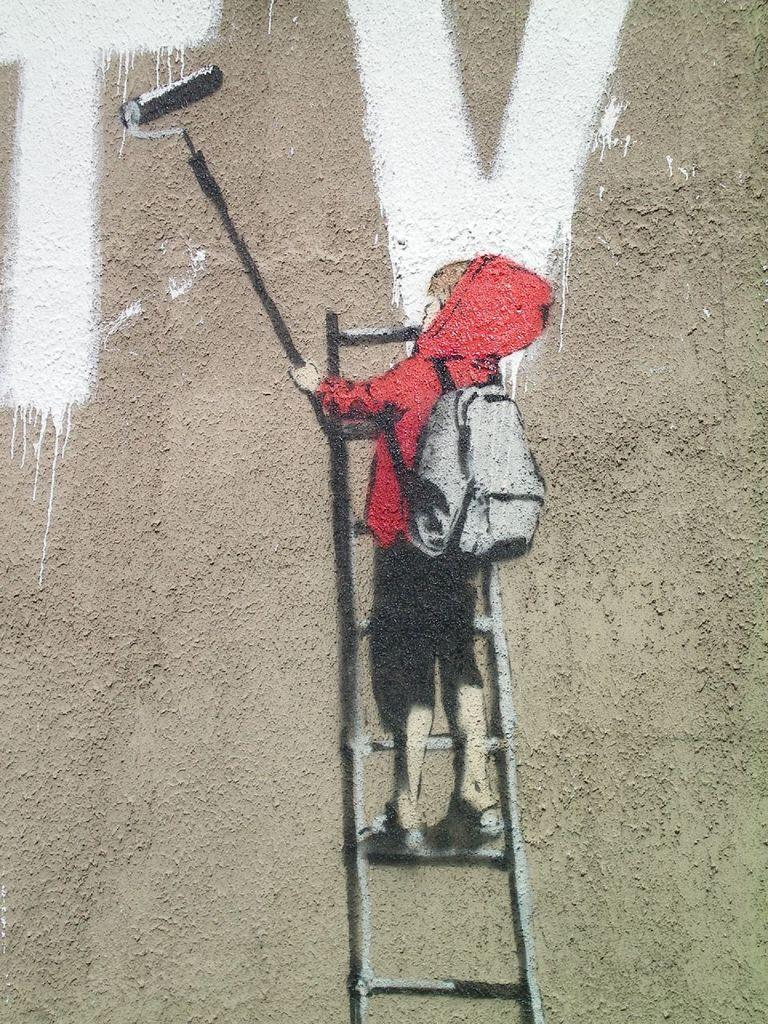What is present on the wall in the image? There is a painting on the wall in the image. What is the subject of the painting? The painting depicts a boy. What is the boy wearing in the painting? The boy is wearing a jacket in the painting. What is the boy holding in the painting? The boy is holding a painting brush in the painting. What is the boy standing on in the painting? The boy is standing on a ladder in the painting. What type of bead is used to create the boy's eyes in the painting? There is no mention of beads or any specific materials used in the painting; it only depicts a boy holding a painting brush. What health advice can be given to the boy in the painting? The boy in the painting is not a real person, so health advice cannot be given to him. 